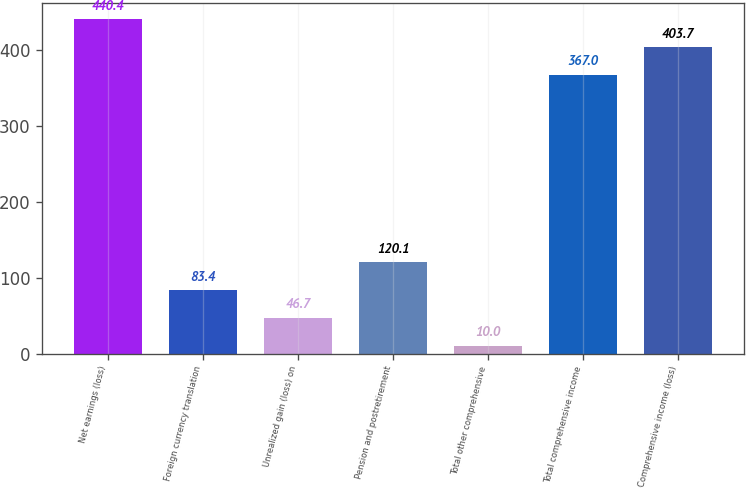<chart> <loc_0><loc_0><loc_500><loc_500><bar_chart><fcel>Net earnings (loss)<fcel>Foreign currency translation<fcel>Unrealized gain (loss) on<fcel>Pension and postretirement<fcel>Total other comprehensive<fcel>Total comprehensive income<fcel>Comprehensive income (loss)<nl><fcel>440.4<fcel>83.4<fcel>46.7<fcel>120.1<fcel>10<fcel>367<fcel>403.7<nl></chart> 